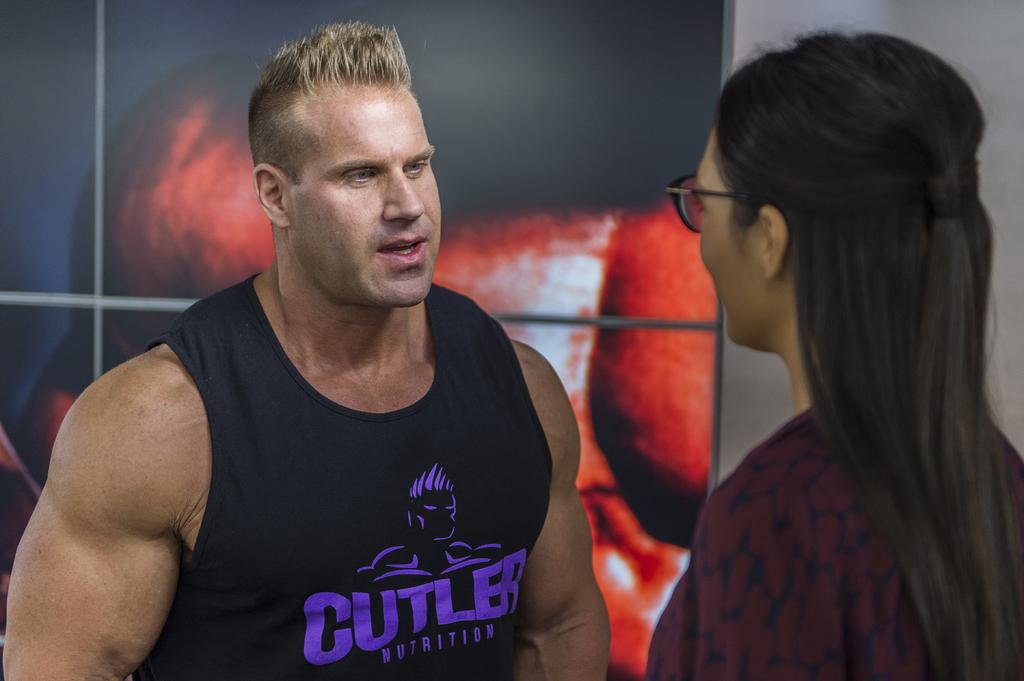<image>
Give a short and clear explanation of the subsequent image. A man with blonde hair and a tank that says cutler on it talking to a woman with long dark hair and glasses 